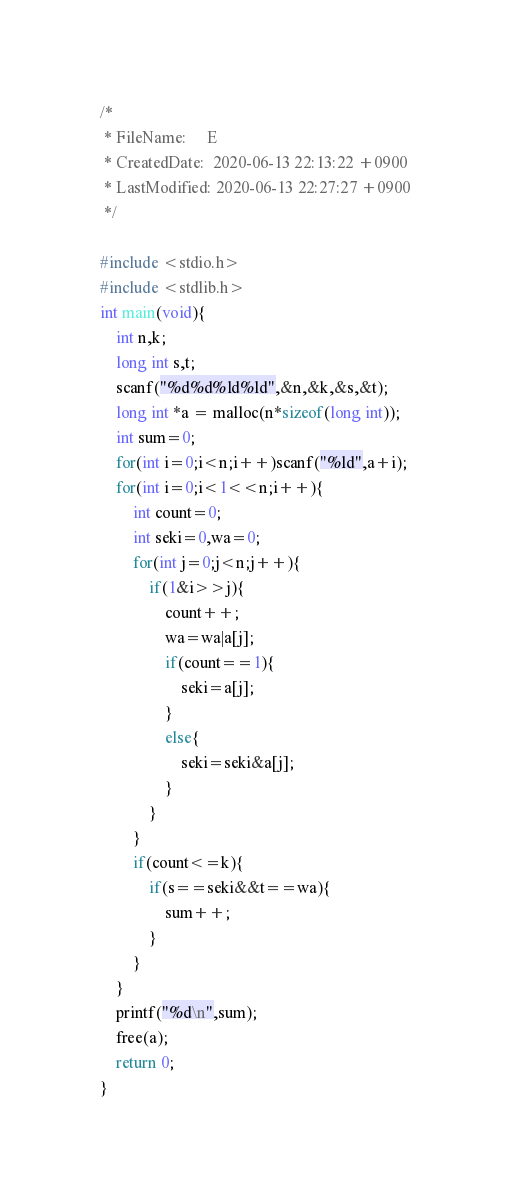<code> <loc_0><loc_0><loc_500><loc_500><_C_>/*
 * FileName:     E
 * CreatedDate:  2020-06-13 22:13:22 +0900
 * LastModified: 2020-06-13 22:27:27 +0900
 */

#include <stdio.h>
#include <stdlib.h>
int main(void){
    int n,k;
    long int s,t;
    scanf("%d%d%ld%ld",&n,&k,&s,&t);
    long int *a = malloc(n*sizeof(long int));
    int sum=0;
    for(int i=0;i<n;i++)scanf("%ld",a+i);
    for(int i=0;i<1<<n;i++){
        int count=0;
        int seki=0,wa=0;
        for(int j=0;j<n;j++){
            if(1&i>>j){
                count++;
                wa=wa|a[j];
                if(count==1){
                    seki=a[j];
                }
                else{
                    seki=seki&a[j];
                }
            }
        }
        if(count<=k){
            if(s==seki&&t==wa){
                sum++;
            }
        }
    }
    printf("%d\n",sum);
    free(a);
    return 0;
}
</code> 